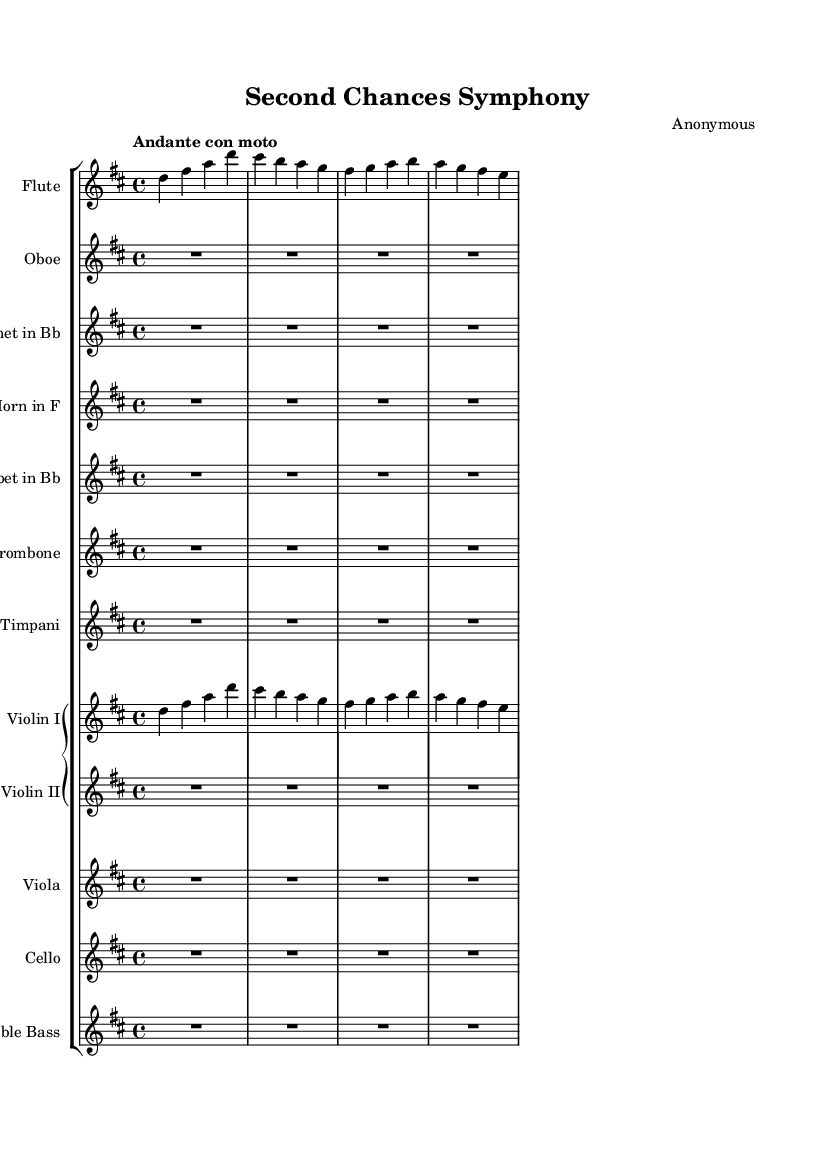What is the key signature of this music? The key signature indicated in the global context of the score is D major, which has two sharps: F# and C#.
Answer: D major What is the time signature of this music? The time signature is found in the global section of the score, which specifies a 4/4 time signature. This means there are four beats per measure and the quarter note gets the beat.
Answer: 4/4 What is the tempo marking of this piece? The tempo marking is specifically stated in the score as "Andante con moto," which indicates a moderately slow tempo with some motion.
Answer: Andante con moto How many instruments are involved in this orchestral work? By counting the individual staffs listed in the score, there are a total of 11 instruments represented: flute, oboe, clarinet, horn, trumpet, trombone, timpani, two violins, viola, cello, and double bass.
Answer: 11 Which instruments are playing a rest for the entire duration of the score? The oboe, clarinet, horn, trombone, violin II, viola, cello, and double bass have a rest symbol (indicated by "R1*4") for the entire duration of this section, meaning they do not play at all.
Answer: Oboe, clarinet, horn, trombone, violin II, viola, cello, double bass What is the transposition of the trumpet? The trumpet part has a transposed key indicated as "Bb," which means it sounds a whole step lower than written. This information is provided next to the instrument name in the score.
Answer: B flat Which instrument plays the first melody in the score? The flute and violin I both start playing melodic lines from the beginning of the score, but the flute part begins first, thus making it the first melody.
Answer: Flute 